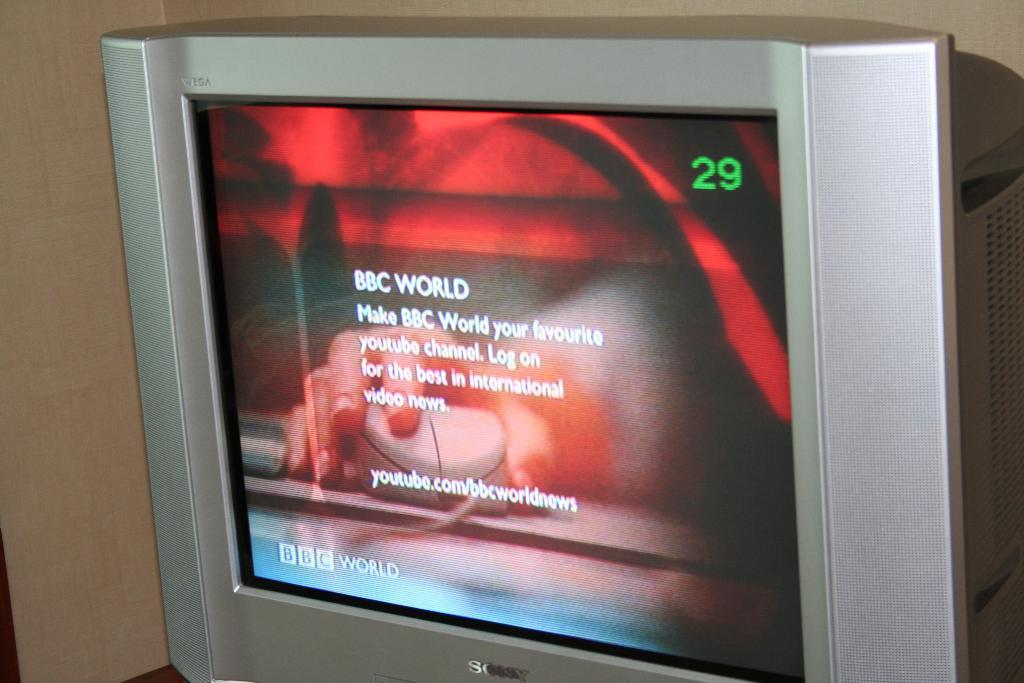<image>
Offer a succinct explanation of the picture presented. The BBC World channel is shown on a TV screen. 